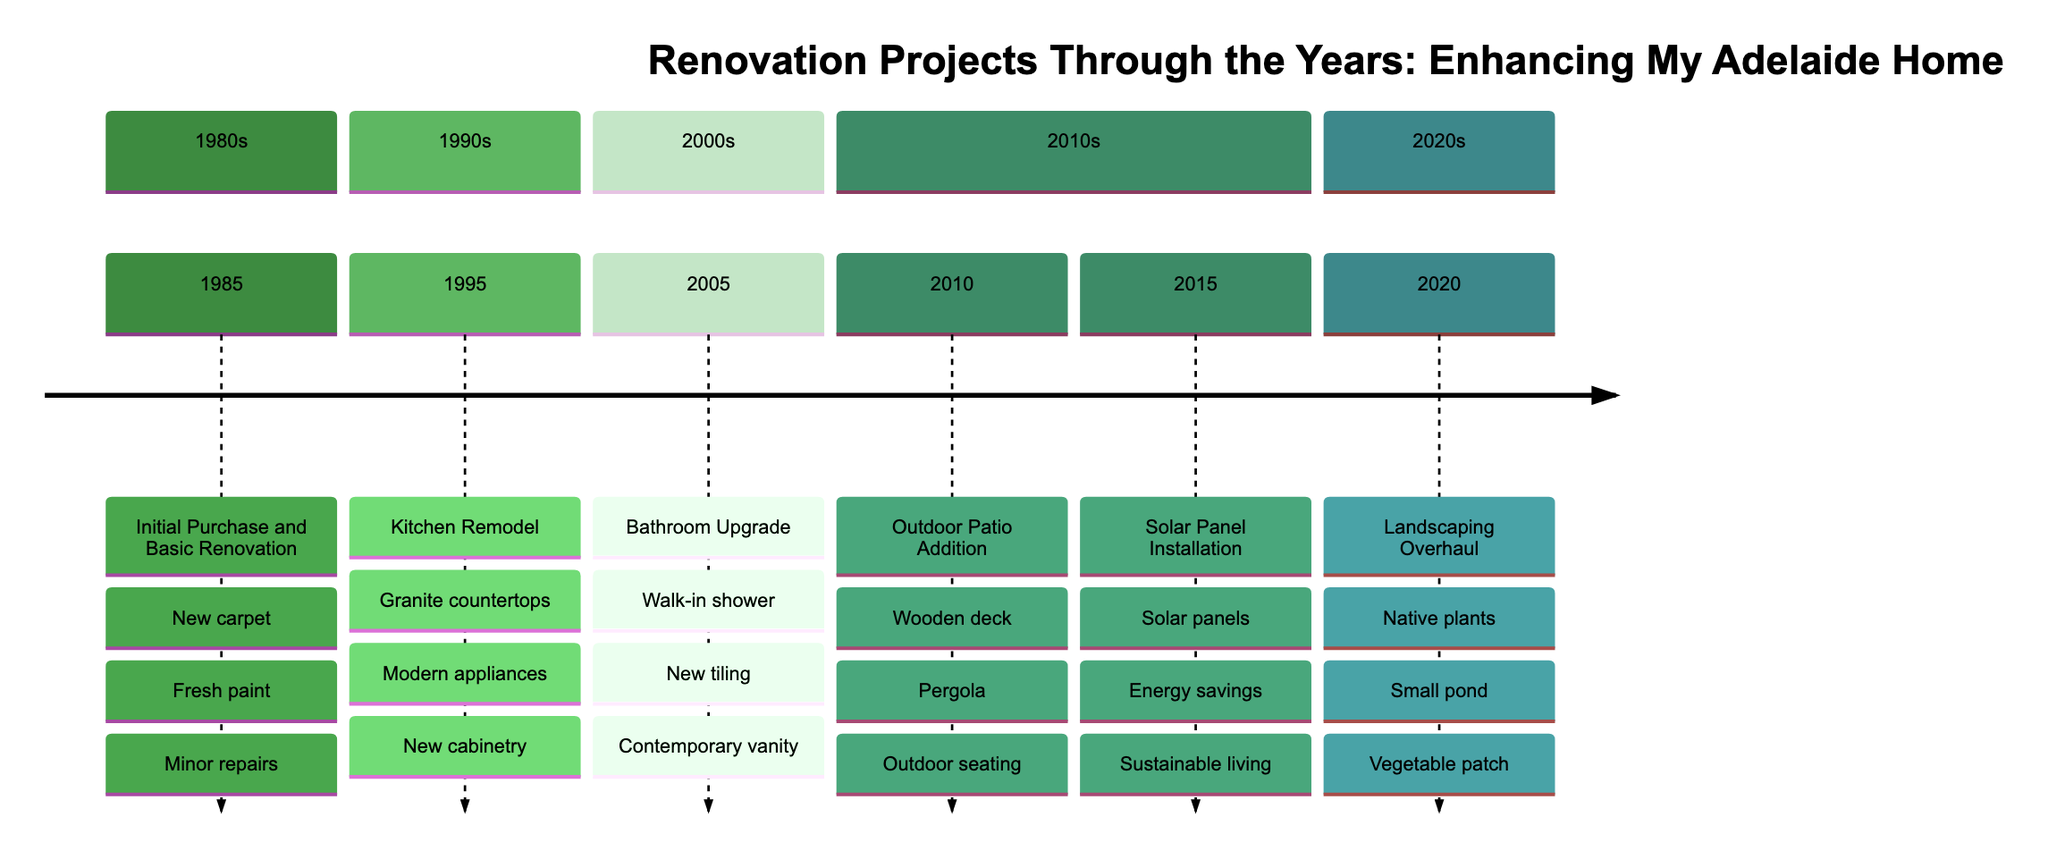What year was the Kitchen Remodel completed? The timeline indicates that the Kitchen Remodel was completed in 1995, as it is listed in the section for the 1990s.
Answer: 1995 What key feature was added during the Bathroom Upgrade? The key features listed for the Bathroom Upgrade include a walk-in shower, new tiling, and a contemporary vanity. One key feature is a walk-in shower.
Answer: Walk-in shower How many renovation projects are listed in the timeline? By counting the individual renovation projects listed throughout the timeline, we find a total of six projects from 1985 to 2020.
Answer: Six Which renovation project included the installation of solar panels? The timeline shows that solar panels were installed during the Solar Panel Installation project in 2015, specifically detailed under the 2010s section.
Answer: Solar Panel Installation What was the focus of the landscaping project completed in 2020? The Landscaping Overhaul in 2020 focused on redesigning the garden, as described in the project’s description and key features, which includes native plants, a small pond, and a vegetable patch.
Answer: Redesigning the garden What enhancement was made to the outdoor space in 2010? The Outdoor Patio Addition in 2010 included the construction of an outdoor patio area with a wooden deck, pergola, and outdoor seating, enhancing the outdoor space.
Answer: Wooden deck, pergola, outdoor seating 